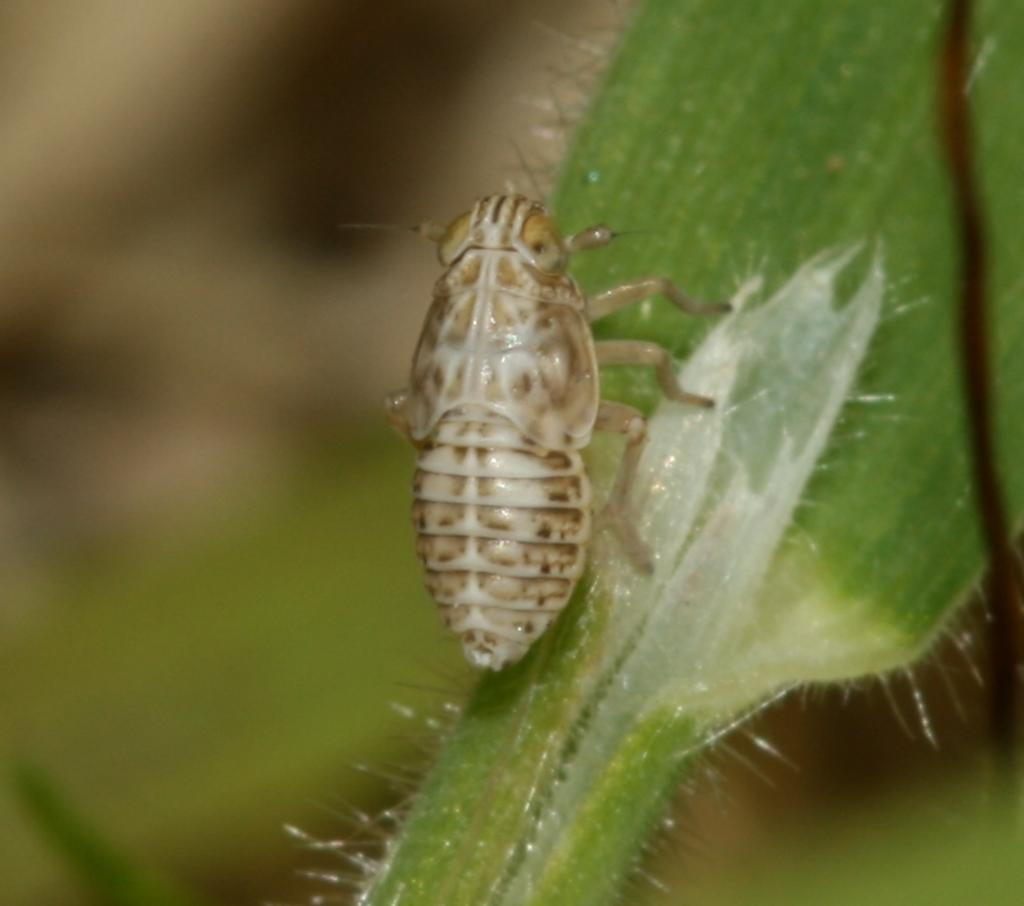What is present on the green leaf in the image? There is a small insect on the green leaf in the image. Can you describe the insect's location on the leaf? The insect is on the green leaf in the image. How does the insect contribute to the profit of the company in the image? There is no company or profit mentioned in the image; it simply shows an insect on a green leaf. 